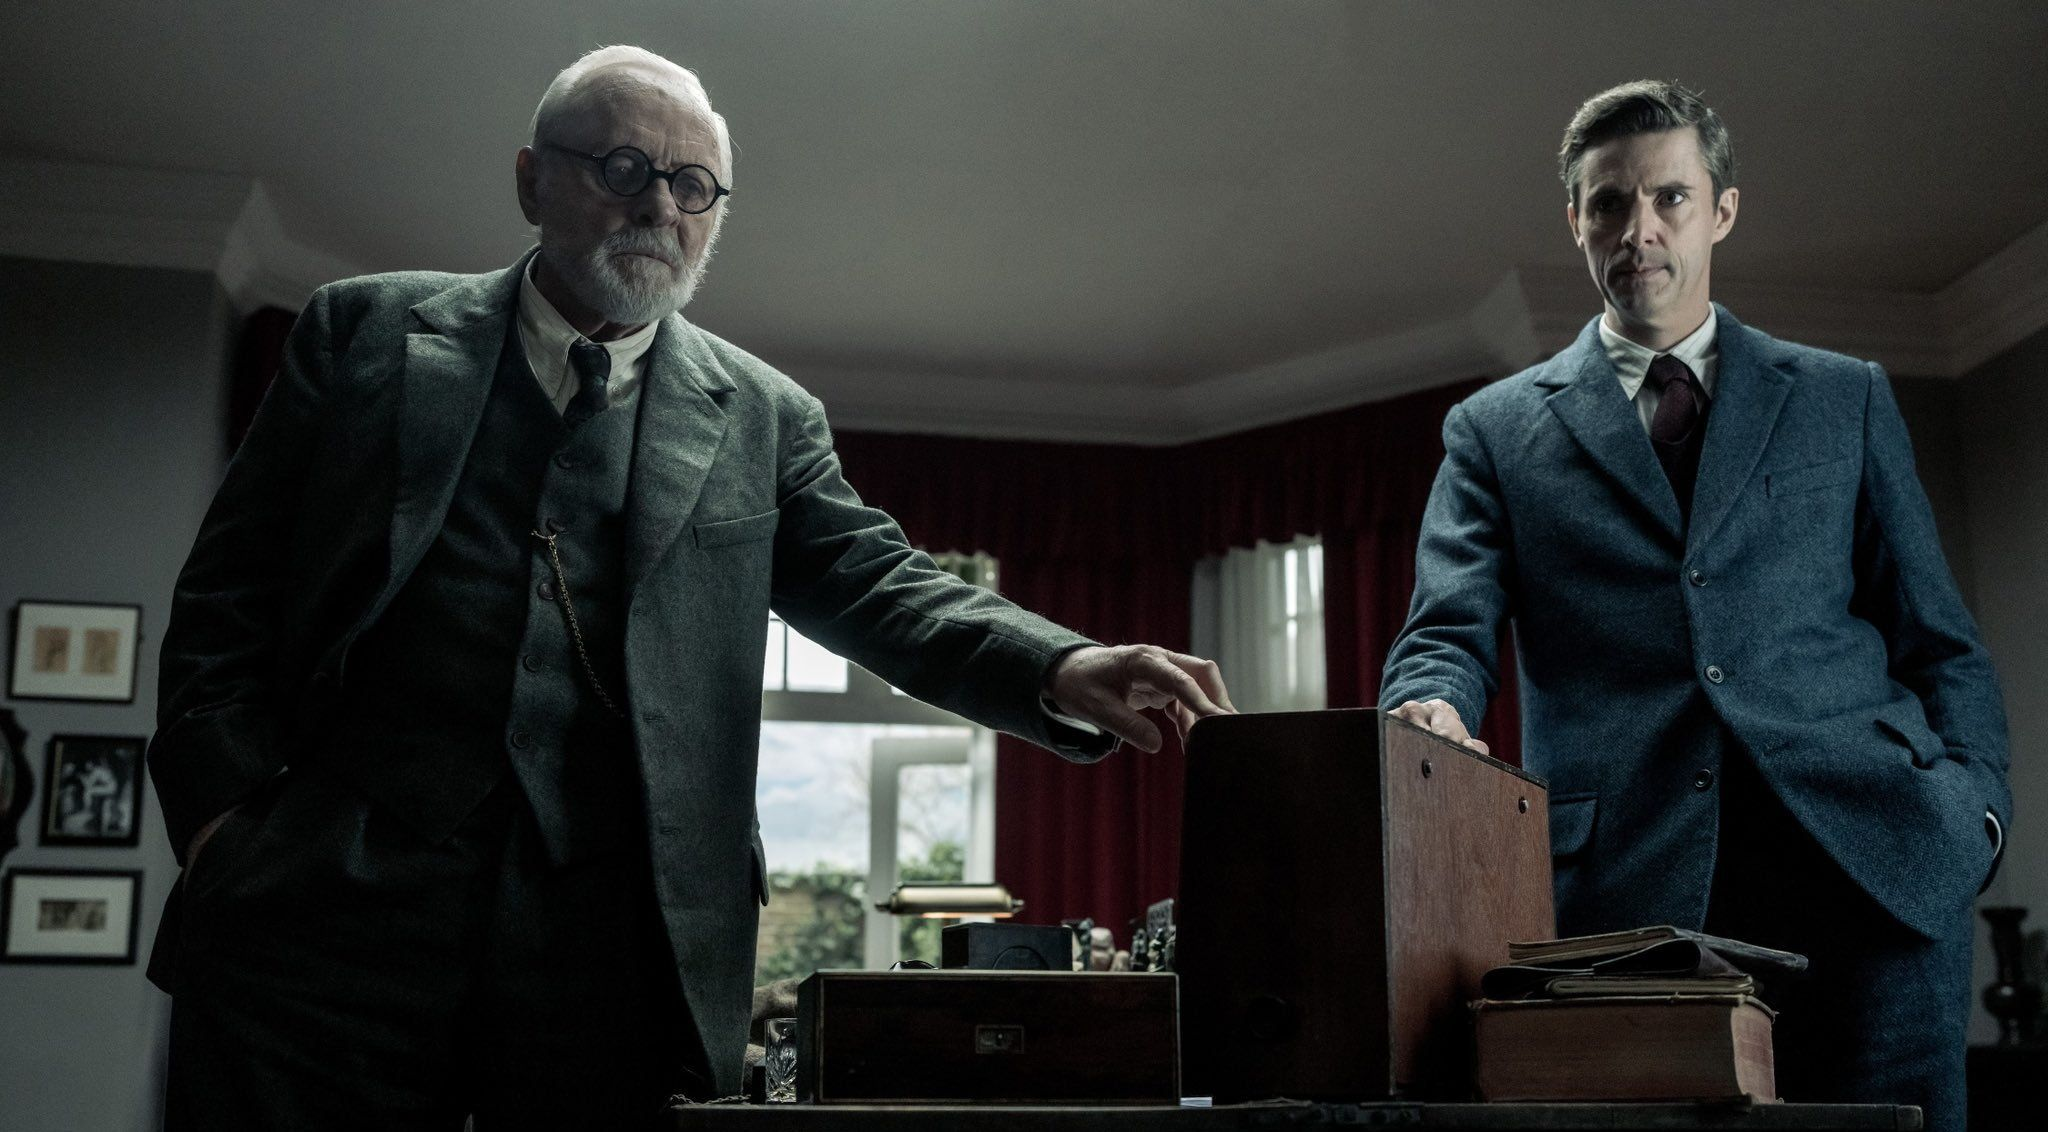Imagine a highly creative scenario involving the two characters and the box. Imagine the box contains an ancient map leading to a hidden treasure guarded by mythical creatures. The elderly man is a seasoned explorer, while the younger man is an ambitious but reckless protégé. Their intense discussion revolves around the ethical implications of pursuing the treasure, knowing the perils that await them both and the power the treasure holds. 